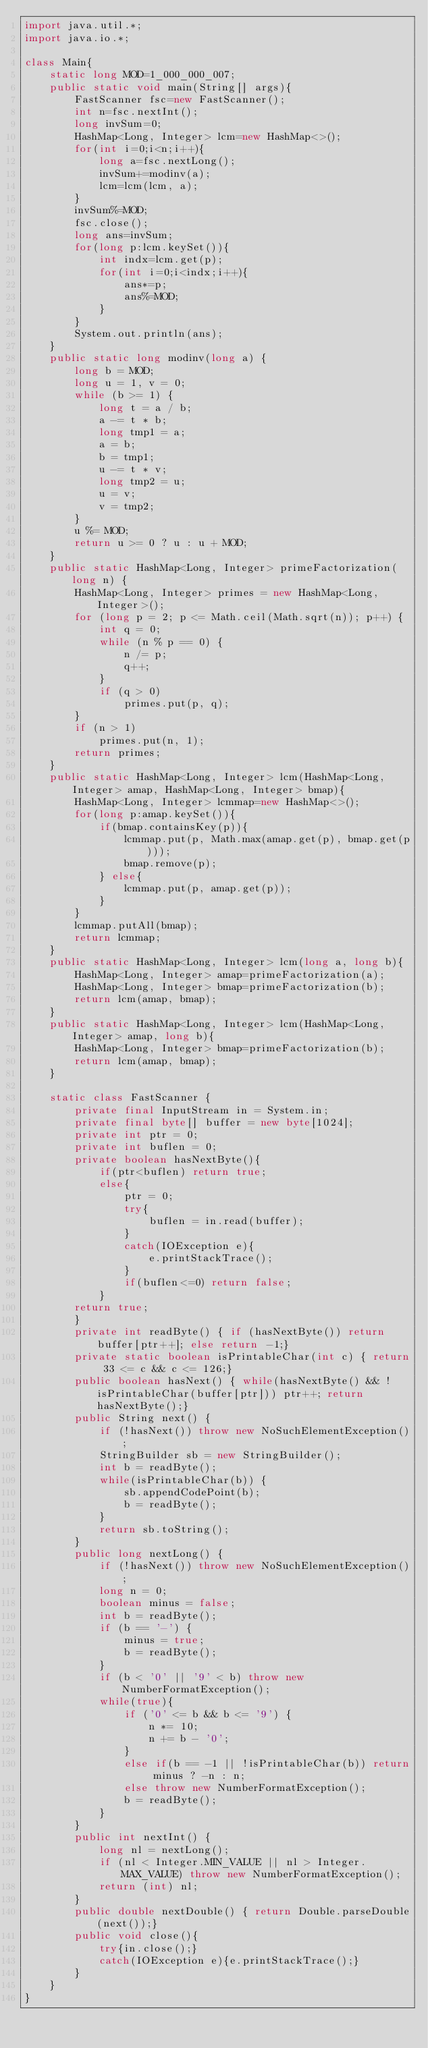<code> <loc_0><loc_0><loc_500><loc_500><_Java_>import java.util.*;
import java.io.*;

class Main{
    static long MOD=1_000_000_007;
    public static void main(String[] args){
        FastScanner fsc=new FastScanner();
        int n=fsc.nextInt();
        long invSum=0;
        HashMap<Long, Integer> lcm=new HashMap<>();
        for(int i=0;i<n;i++){
            long a=fsc.nextLong();
            invSum+=modinv(a);
            lcm=lcm(lcm, a);
        }
        invSum%=MOD;
        fsc.close();
        long ans=invSum;
        for(long p:lcm.keySet()){
            int indx=lcm.get(p);
            for(int i=0;i<indx;i++){
                ans*=p;
                ans%=MOD;
            }
        }
        System.out.println(ans);
    }
    public static long modinv(long a) {
        long b = MOD;
        long u = 1, v = 0;
        while (b >= 1) {
            long t = a / b;
            a -= t * b;
            long tmp1 = a;
            a = b;
            b = tmp1;
            u -= t * v;
            long tmp2 = u;
            u = v;
            v = tmp2;
        }
        u %= MOD;
        return u >= 0 ? u : u + MOD;
    }
    public static HashMap<Long, Integer> primeFactorization(long n) {
        HashMap<Long, Integer> primes = new HashMap<Long, Integer>();
        for (long p = 2; p <= Math.ceil(Math.sqrt(n)); p++) {
            int q = 0;
            while (n % p == 0) {
                n /= p;
                q++;
            }
            if (q > 0)
                primes.put(p, q);
        }
        if (n > 1)
            primes.put(n, 1);
        return primes;
    }
    public static HashMap<Long, Integer> lcm(HashMap<Long, Integer> amap, HashMap<Long, Integer> bmap){
        HashMap<Long, Integer> lcmmap=new HashMap<>();
        for(long p:amap.keySet()){
            if(bmap.containsKey(p)){
                lcmmap.put(p, Math.max(amap.get(p), bmap.get(p)));
                bmap.remove(p);
            } else{
                lcmmap.put(p, amap.get(p));
            }
        }
        lcmmap.putAll(bmap);
        return lcmmap;
    }
    public static HashMap<Long, Integer> lcm(long a, long b){
        HashMap<Long, Integer> amap=primeFactorization(a);
        HashMap<Long, Integer> bmap=primeFactorization(b);
        return lcm(amap, bmap);
    }
    public static HashMap<Long, Integer> lcm(HashMap<Long, Integer> amap, long b){
        HashMap<Long, Integer> bmap=primeFactorization(b);
        return lcm(amap, bmap);
    }

    static class FastScanner {
        private final InputStream in = System.in;
        private final byte[] buffer = new byte[1024];
        private int ptr = 0;
        private int buflen = 0;
        private boolean hasNextByte(){
            if(ptr<buflen) return true;
            else{
                ptr = 0;
                try{
                    buflen = in.read(buffer);
                }
                catch(IOException e){
                    e.printStackTrace();
                }
                if(buflen<=0) return false;
            }
        return true;
        }
        private int readByte() { if (hasNextByte()) return buffer[ptr++]; else return -1;}
        private static boolean isPrintableChar(int c) { return 33 <= c && c <= 126;}
        public boolean hasNext() { while(hasNextByte() && !isPrintableChar(buffer[ptr])) ptr++; return hasNextByte();}
        public String next() {
            if (!hasNext()) throw new NoSuchElementException();
            StringBuilder sb = new StringBuilder();
            int b = readByte();
            while(isPrintableChar(b)) {
                sb.appendCodePoint(b);
                b = readByte();
            }
            return sb.toString();
        }
        public long nextLong() {
            if (!hasNext()) throw new NoSuchElementException();
            long n = 0;
            boolean minus = false;
            int b = readByte();
            if (b == '-') {
                minus = true;
                b = readByte();
            }
            if (b < '0' || '9' < b) throw new NumberFormatException();
            while(true){
                if ('0' <= b && b <= '9') {
                    n *= 10;
                    n += b - '0';
                }
                else if(b == -1 || !isPrintableChar(b)) return minus ? -n : n;
                else throw new NumberFormatException();
                b = readByte();
            }
        }
        public int nextInt() {
            long nl = nextLong();
            if (nl < Integer.MIN_VALUE || nl > Integer.MAX_VALUE) throw new NumberFormatException();
            return (int) nl;
        }
        public double nextDouble() { return Double.parseDouble(next());}
        public void close(){
            try{in.close();}
            catch(IOException e){e.printStackTrace();}
        }
    }
}
</code> 